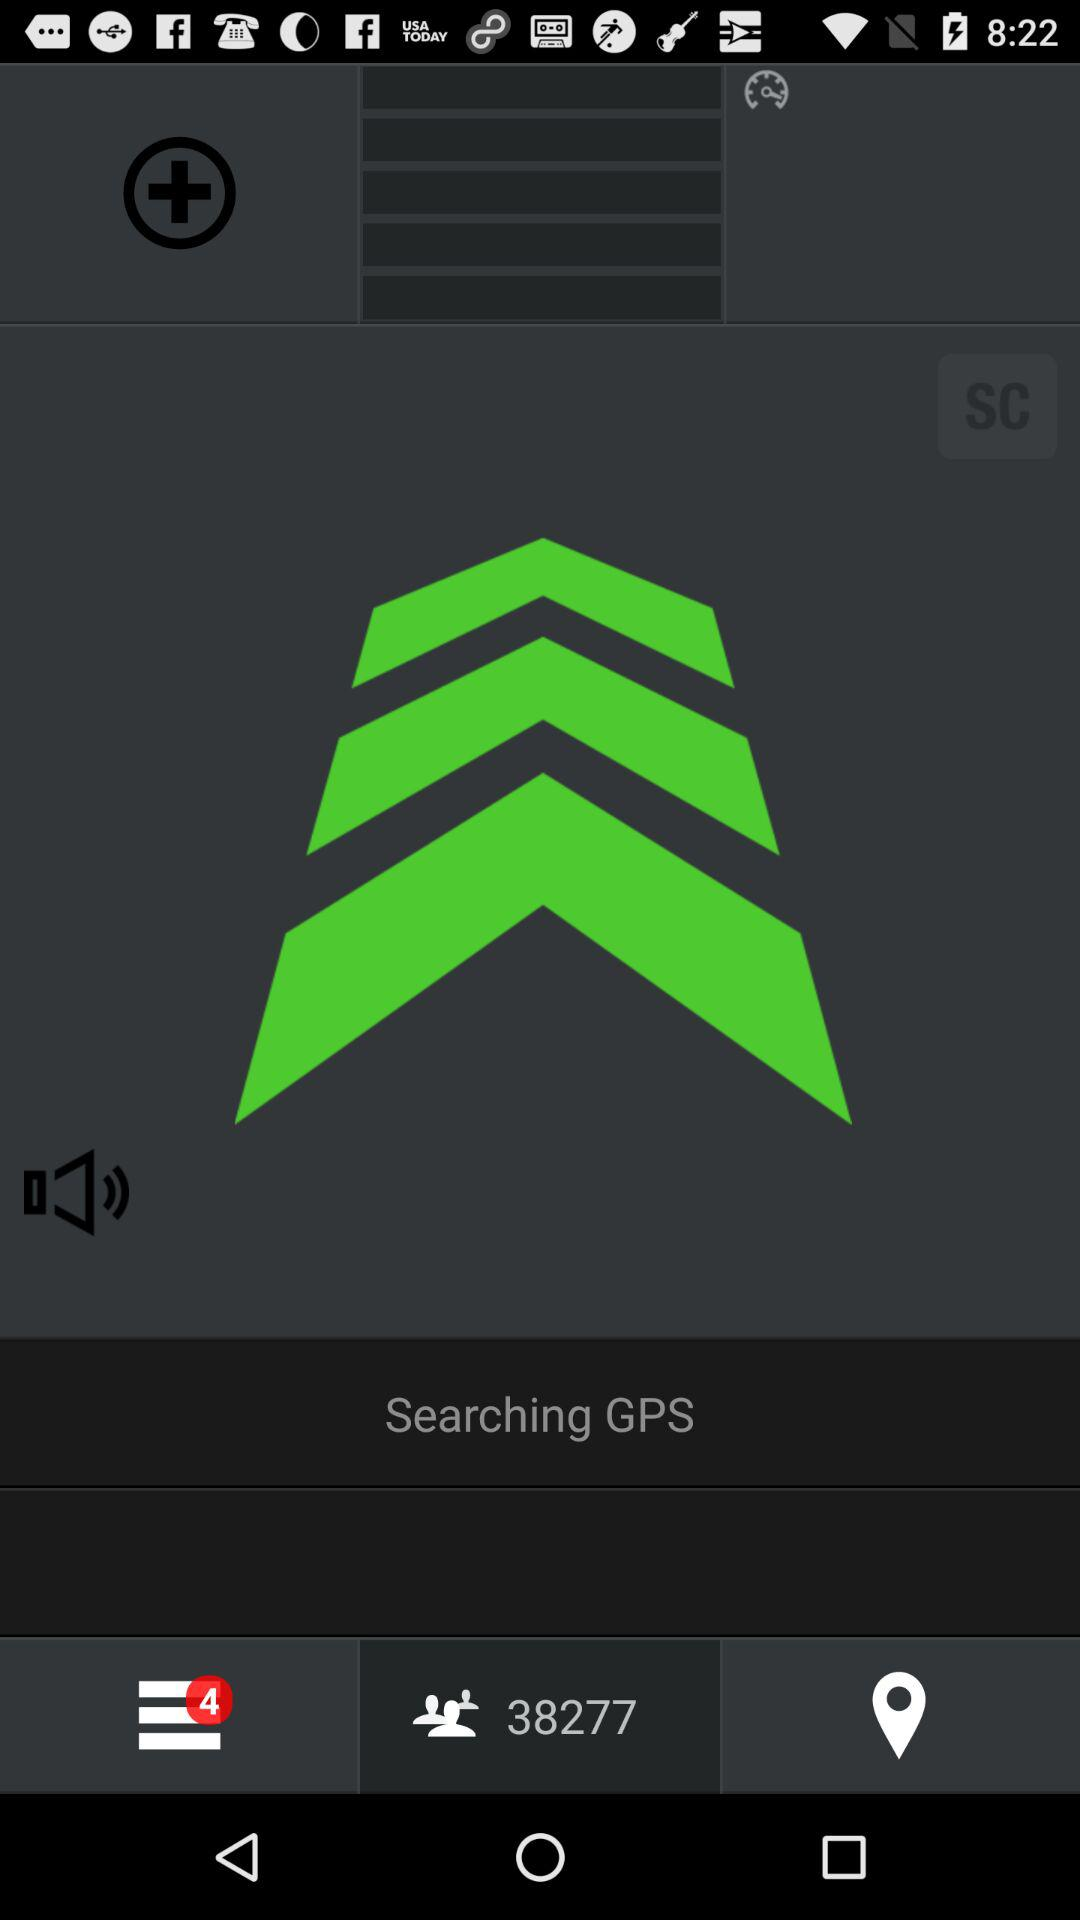How many users are mentioned? There are 38277 mentioned users. 